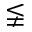Convert formula to latex. <formula><loc_0><loc_0><loc_500><loc_500>\lneqq</formula> 